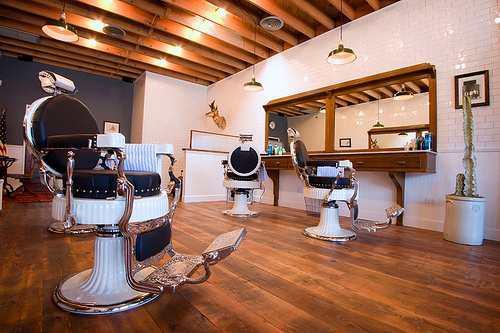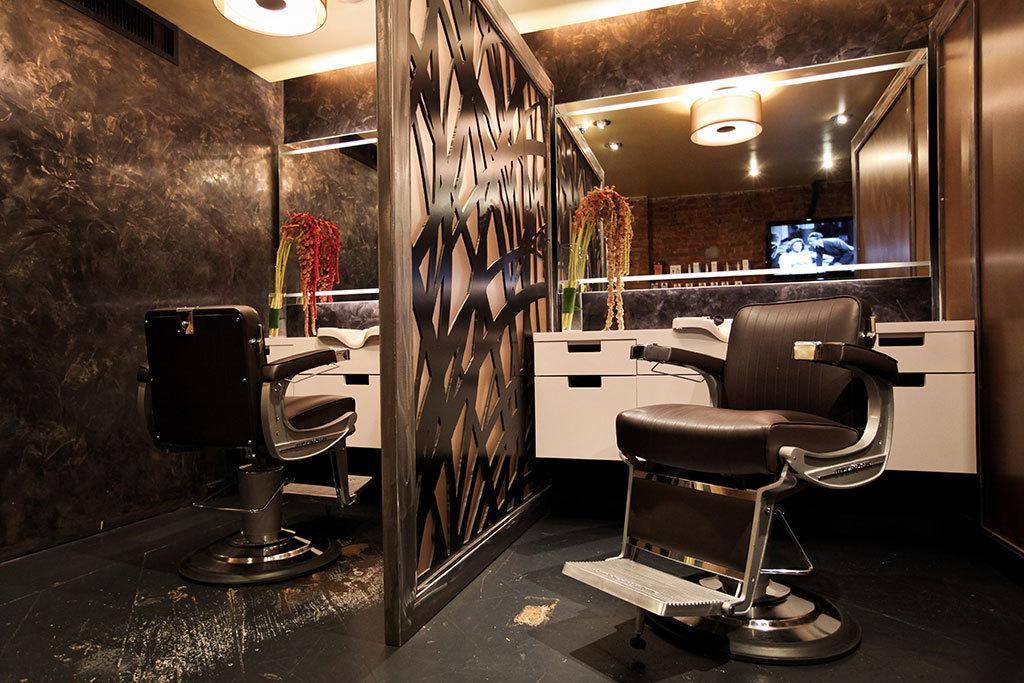The first image is the image on the left, the second image is the image on the right. Assess this claim about the two images: "There are people in one image but not in the other image.". Correct or not? Answer yes or no. No. 